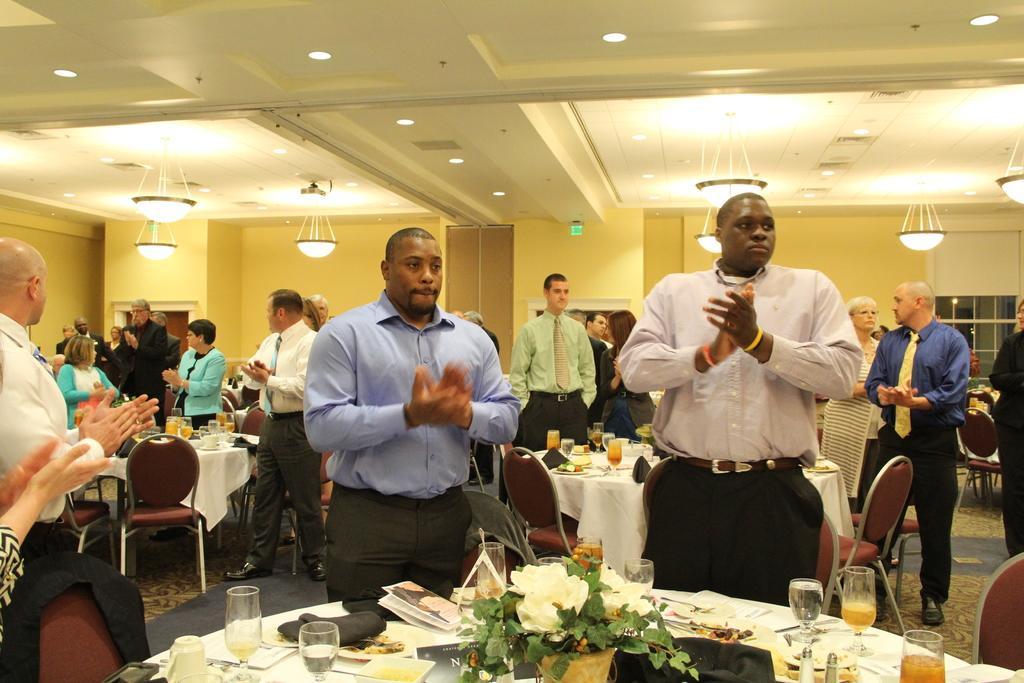Describe this image in one or two sentences. In this image I can see group of people standing and wearing different color dress. I can see few glasses,papers,books and few objects on the table. I can see few chairs,windows,and lights. 